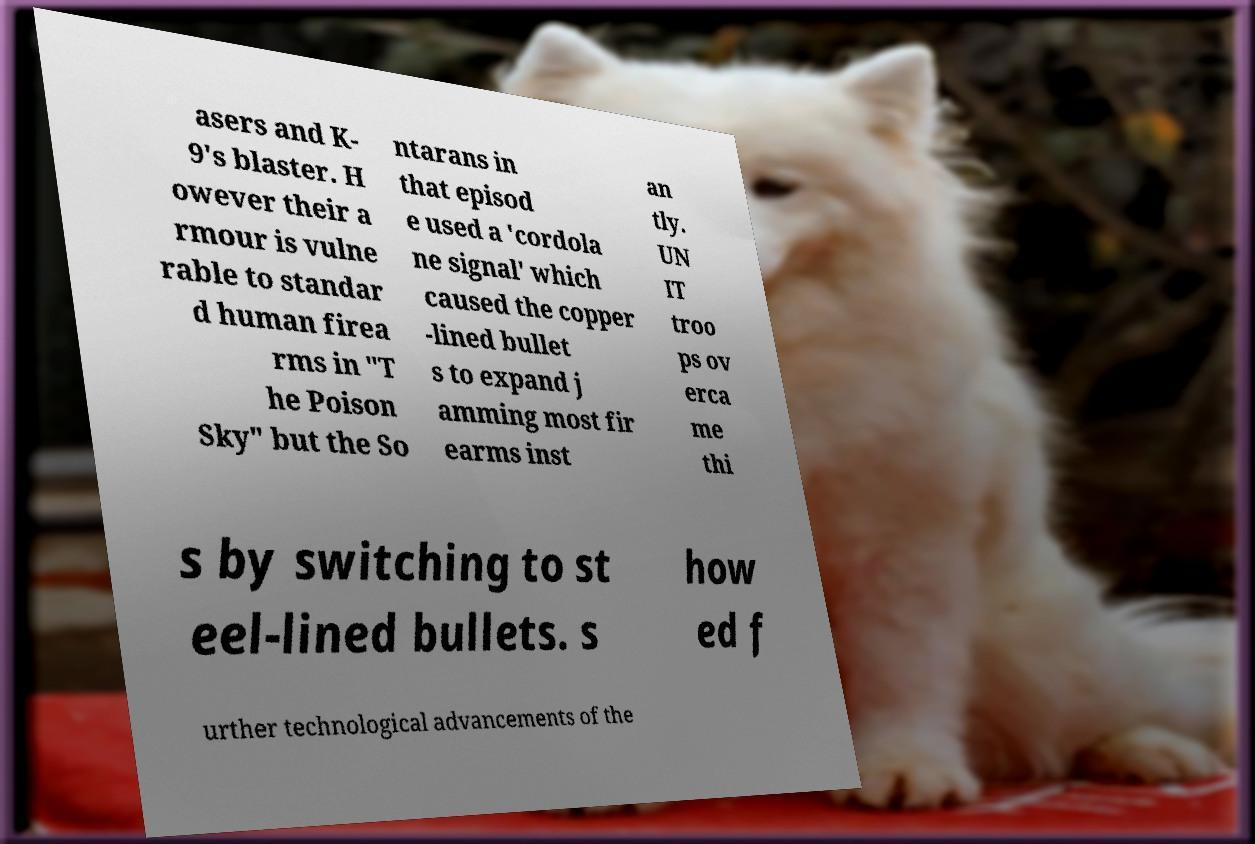Could you extract and type out the text from this image? asers and K- 9's blaster. H owever their a rmour is vulne rable to standar d human firea rms in "T he Poison Sky" but the So ntarans in that episod e used a 'cordola ne signal' which caused the copper -lined bullet s to expand j amming most fir earms inst an tly. UN IT troo ps ov erca me thi s by switching to st eel-lined bullets. s how ed f urther technological advancements of the 